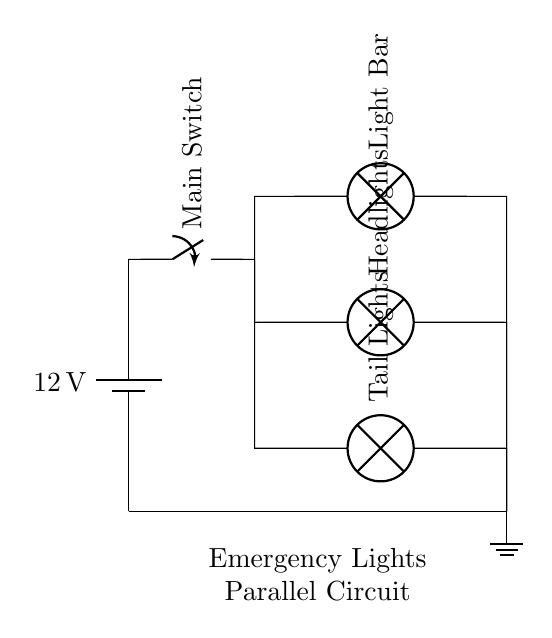What is the voltage of this circuit? The voltage is twelve volts, which is provided by the battery connected at the top of the circuit diagram. The battery is the source of the circuit's power.
Answer: twelve volts What components are connected in parallel? The components connected in parallel are the light bar, headlights, and tail lights. In a parallel circuit, each device is connected directly to the voltage source, allowing them to operate independently.
Answer: light bar, headlights, tail lights What is the role of the main switch? The main switch controls the flow of electricity to the entire circuit. When the switch is closed, it allows current to flow, turning on all lights connected in parallel.
Answer: control electricity flow If one light fails, what happens to the others? If one light fails, the others remain operational because they are connected in parallel. This is a key feature of parallel circuits, enhancing reliability for emergency lights.
Answer: others remain operational How many lights are present in the circuit? There are three lights present in the circuit: the light bar, headlights, and tail lights. This can be counted directly from the components shown in the diagram.
Answer: three lights What type of circuit is this? This is a parallel circuit, as indicated by the multiple branches connected to the same two points of the voltage source, allowing multiple paths for current.
Answer: parallel circuit 